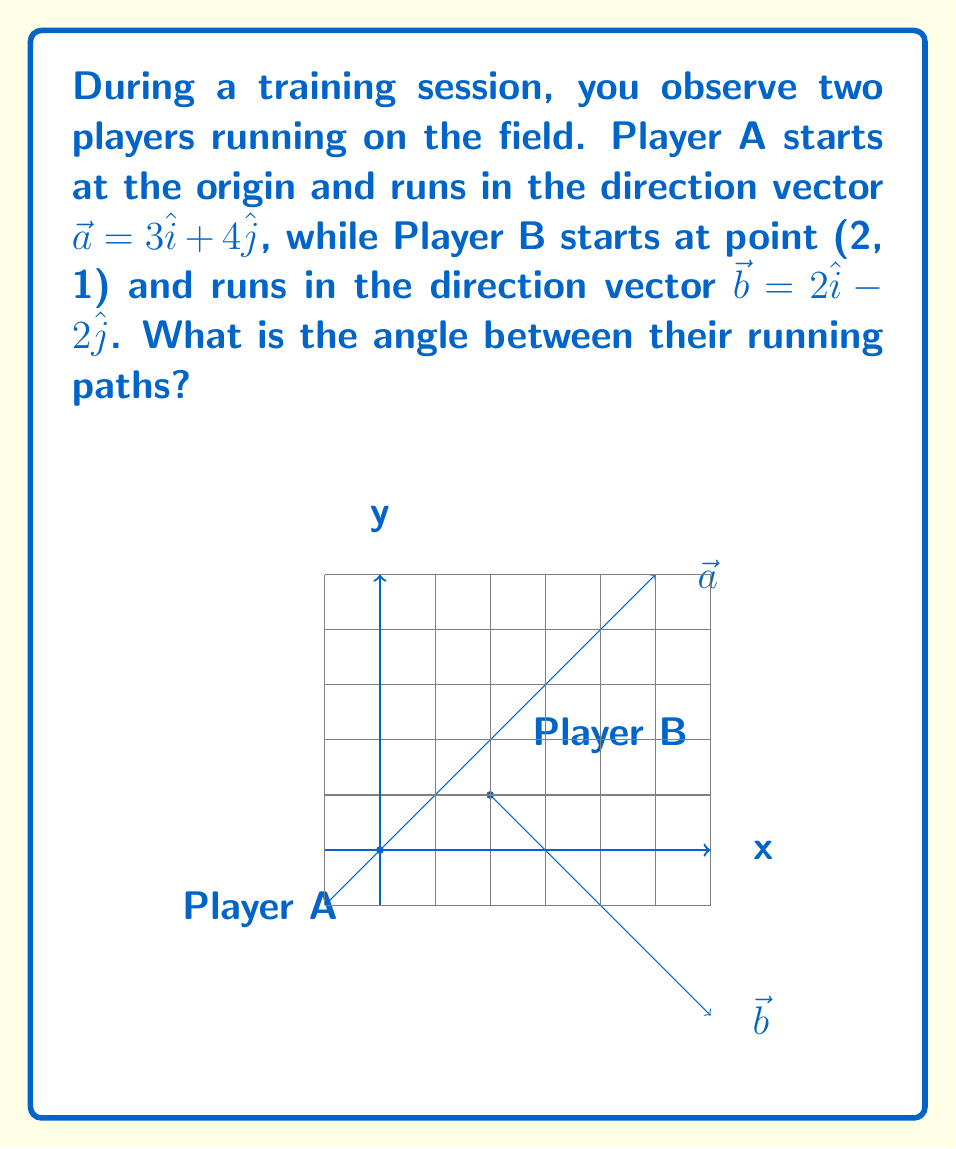Provide a solution to this math problem. To find the angle between two vectors, we can use the dot product formula:

$$\cos \theta = \frac{\vec{a} \cdot \vec{b}}{|\vec{a}||\vec{b}|}$$

Step 1: Calculate the dot product $\vec{a} \cdot \vec{b}$
$$\vec{a} \cdot \vec{b} = (3)(2) + (4)(-2) = 6 - 8 = -2$$

Step 2: Calculate the magnitudes of $\vec{a}$ and $\vec{b}$
$$|\vec{a}| = \sqrt{3^2 + 4^2} = \sqrt{9 + 16} = \sqrt{25} = 5$$
$$|\vec{b}| = \sqrt{2^2 + (-2)^2} = \sqrt{4 + 4} = \sqrt{8} = 2\sqrt{2}$$

Step 3: Substitute into the dot product formula
$$\cos \theta = \frac{-2}{5(2\sqrt{2})} = \frac{-1}{5\sqrt{2}}$$

Step 4: Take the inverse cosine (arccos) of both sides
$$\theta = \arccos(\frac{-1}{5\sqrt{2}})$$

Step 5: Calculate the result (rounded to two decimal places)
$$\theta \approx 1.82 \text{ radians}$$

Convert to degrees:
$$\theta \approx 1.82 \times \frac{180^{\circ}}{\pi} \approx 104.48^{\circ}$$
Answer: $104.48^{\circ}$ 